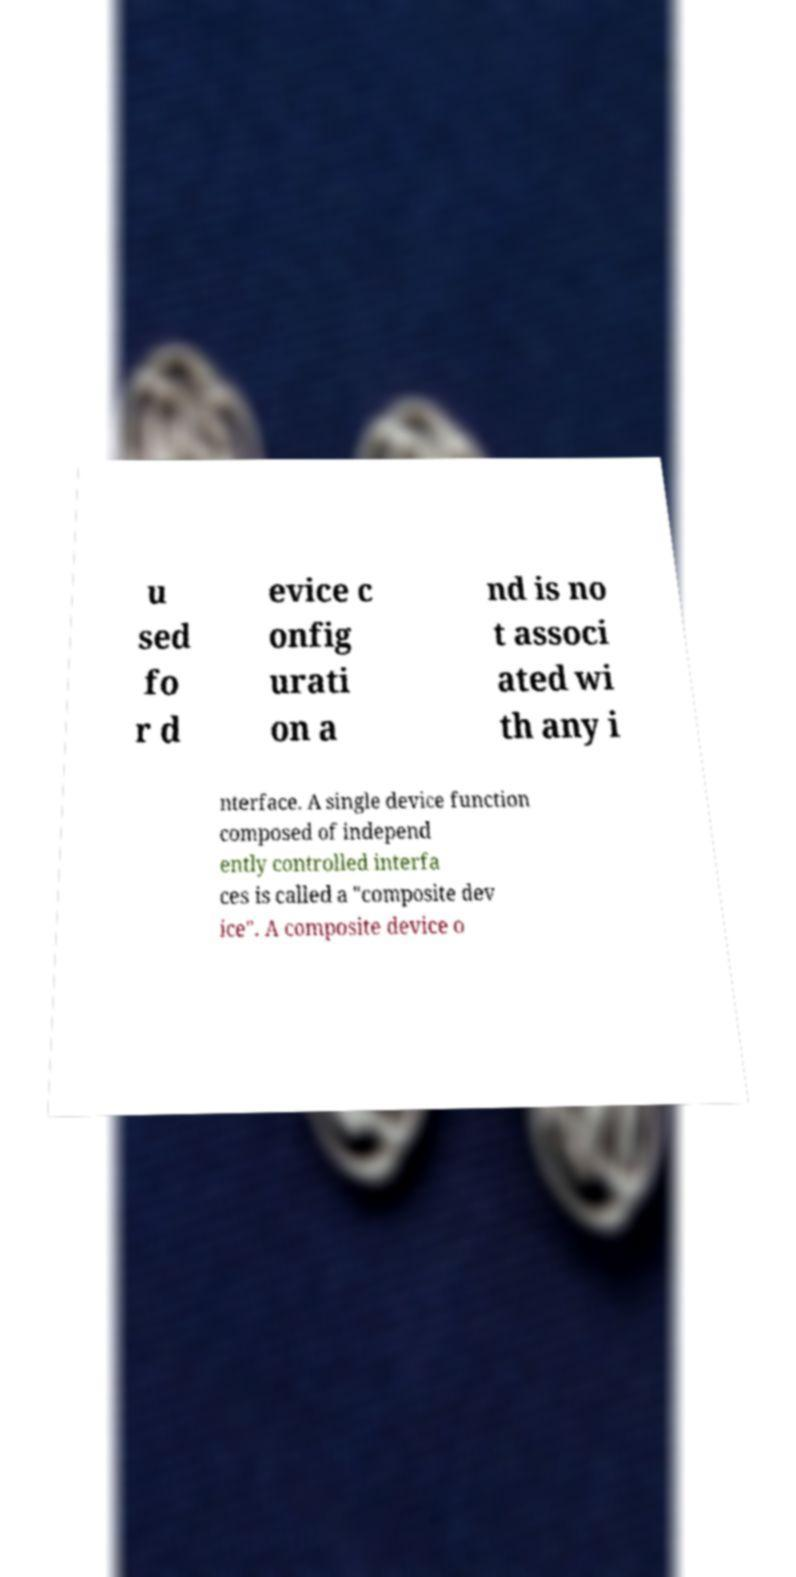Please identify and transcribe the text found in this image. u sed fo r d evice c onfig urati on a nd is no t associ ated wi th any i nterface. A single device function composed of independ ently controlled interfa ces is called a "composite dev ice". A composite device o 